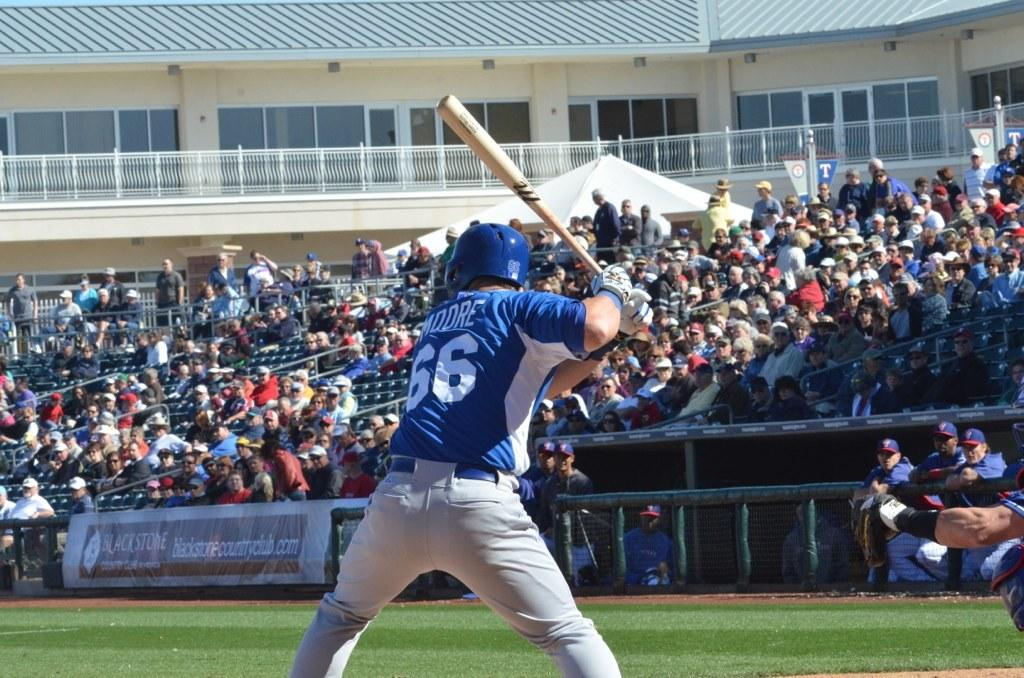<image>
Write a terse but informative summary of the picture. A baseball player wearing a number 66 t-shirt is preparing to swing his bat 